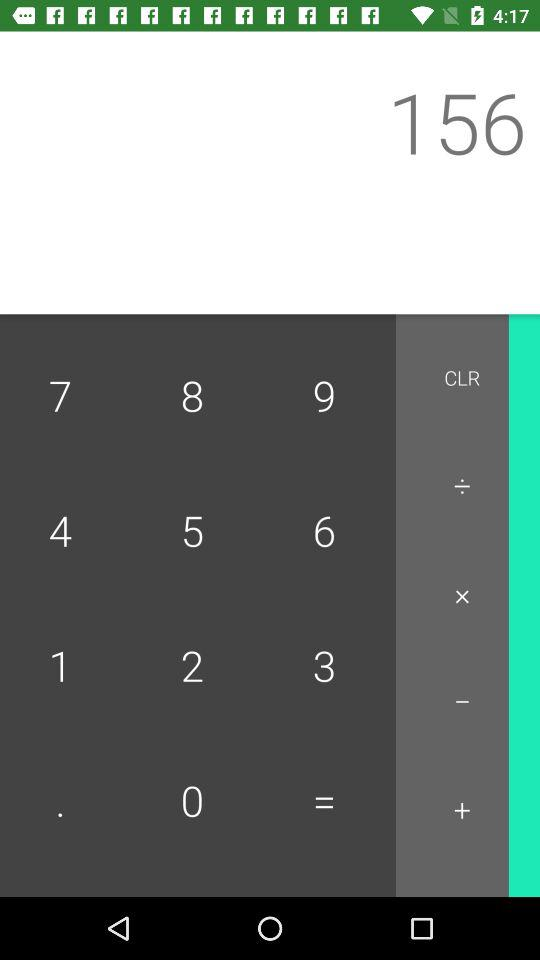What is the number entered as input? The number entered as input is 156. 